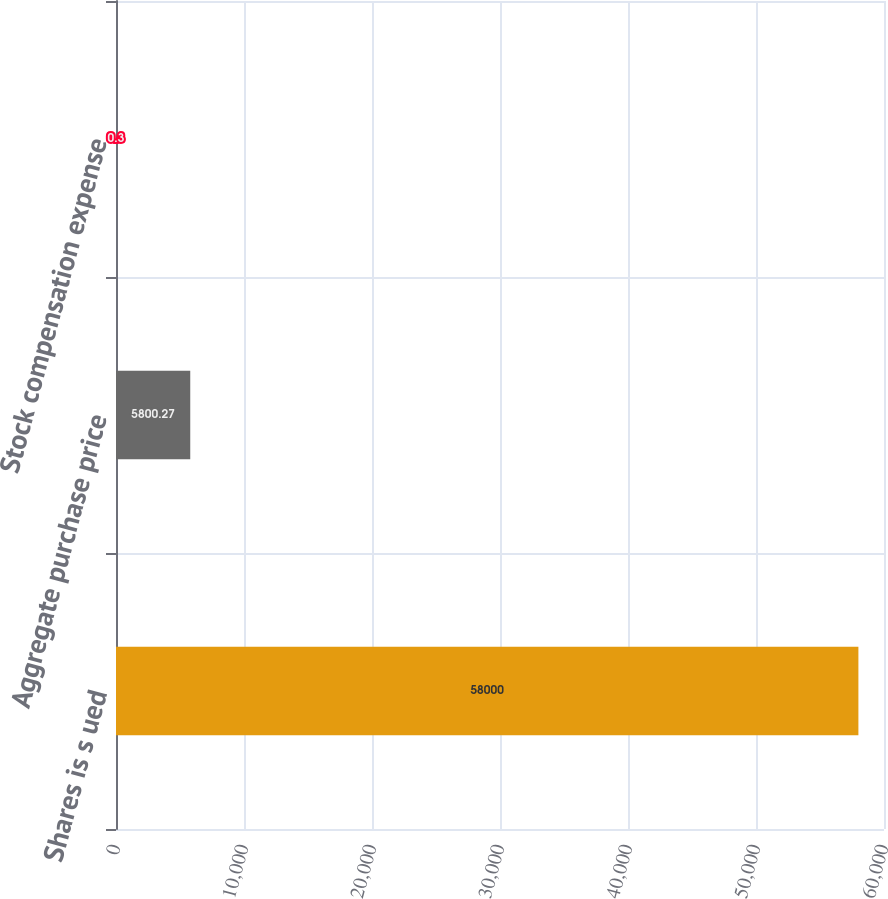Convert chart. <chart><loc_0><loc_0><loc_500><loc_500><bar_chart><fcel>Shares is s ued<fcel>Aggregate purchase price<fcel>Stock compensation expense<nl><fcel>58000<fcel>5800.27<fcel>0.3<nl></chart> 